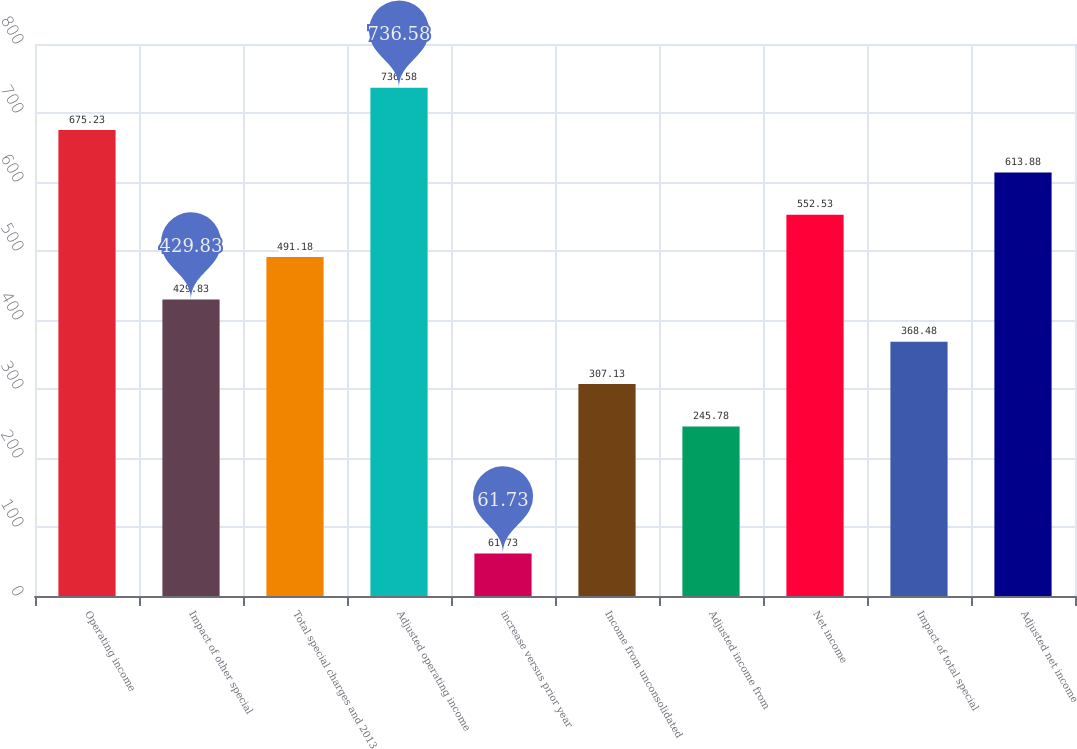Convert chart to OTSL. <chart><loc_0><loc_0><loc_500><loc_500><bar_chart><fcel>Operating income<fcel>Impact of other special<fcel>Total special charges and 2013<fcel>Adjusted operating income<fcel>increase versus prior year<fcel>Income from unconsolidated<fcel>Adjusted income from<fcel>Net income<fcel>Impact of total special<fcel>Adjusted net income<nl><fcel>675.23<fcel>429.83<fcel>491.18<fcel>736.58<fcel>61.73<fcel>307.13<fcel>245.78<fcel>552.53<fcel>368.48<fcel>613.88<nl></chart> 